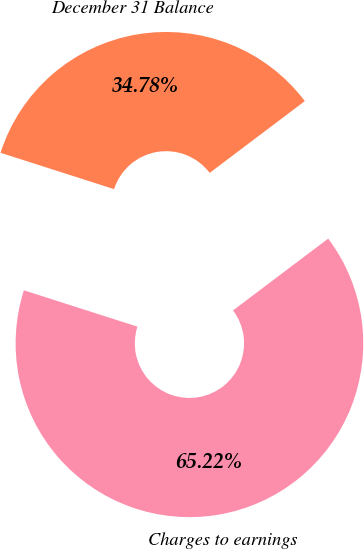<chart> <loc_0><loc_0><loc_500><loc_500><pie_chart><fcel>Charges to earnings<fcel>December 31 Balance<nl><fcel>65.22%<fcel>34.78%<nl></chart> 